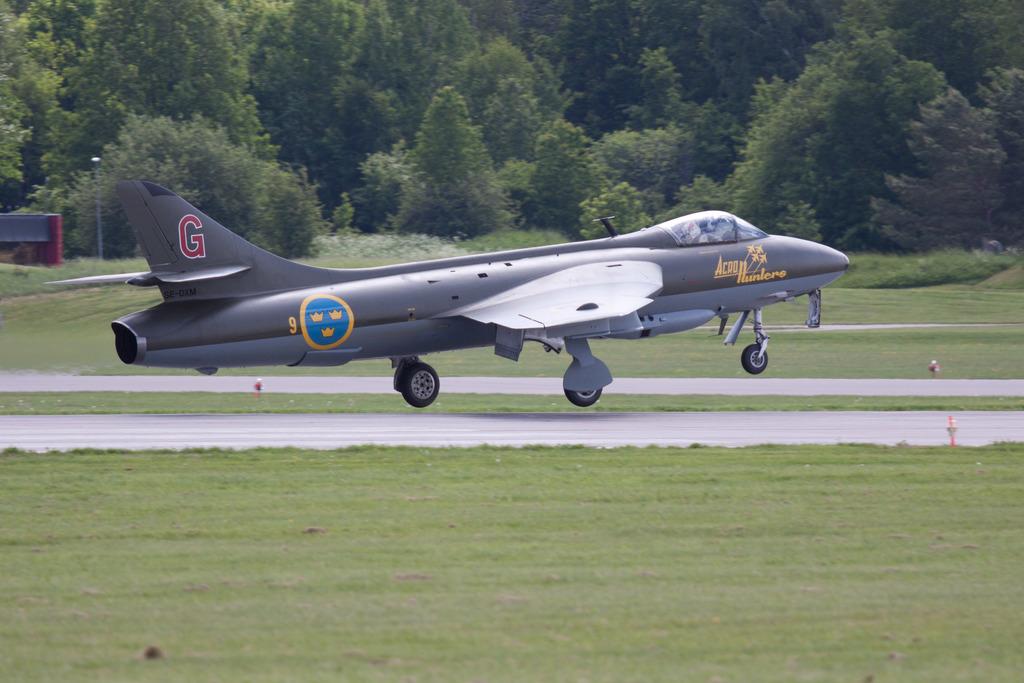What is the plane number?
Keep it short and to the point. 9. 